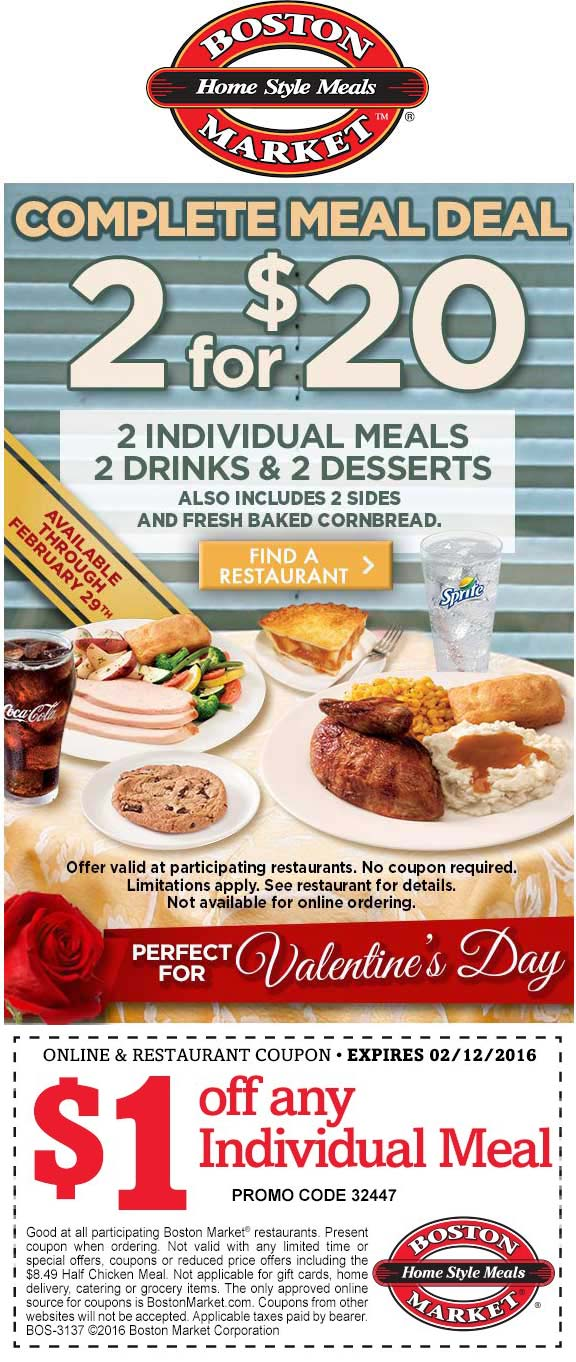Considering the expiry date of the coupon, what might be the significance of the chosen time frame for the promotion? The expiry date of the coupon, set for February 12, 2016, aligns strategically with Valentine's Day preparations, offering a timeframe that likely aims to capture the increased consumer interest in dining out during this romantic period. The promotion begins on January 29 and extends up to the day before Valentine’s Day, optimizing potential customer engagement by positioning these two weeks as an ideal time for romantic dinners. The marketing materials, evident through the use of red roses and heart motifs, are tailored to resonate with the themes of love and celebration, making the deal appealing to couples looking for special offers on home-style meals during this festive season. 